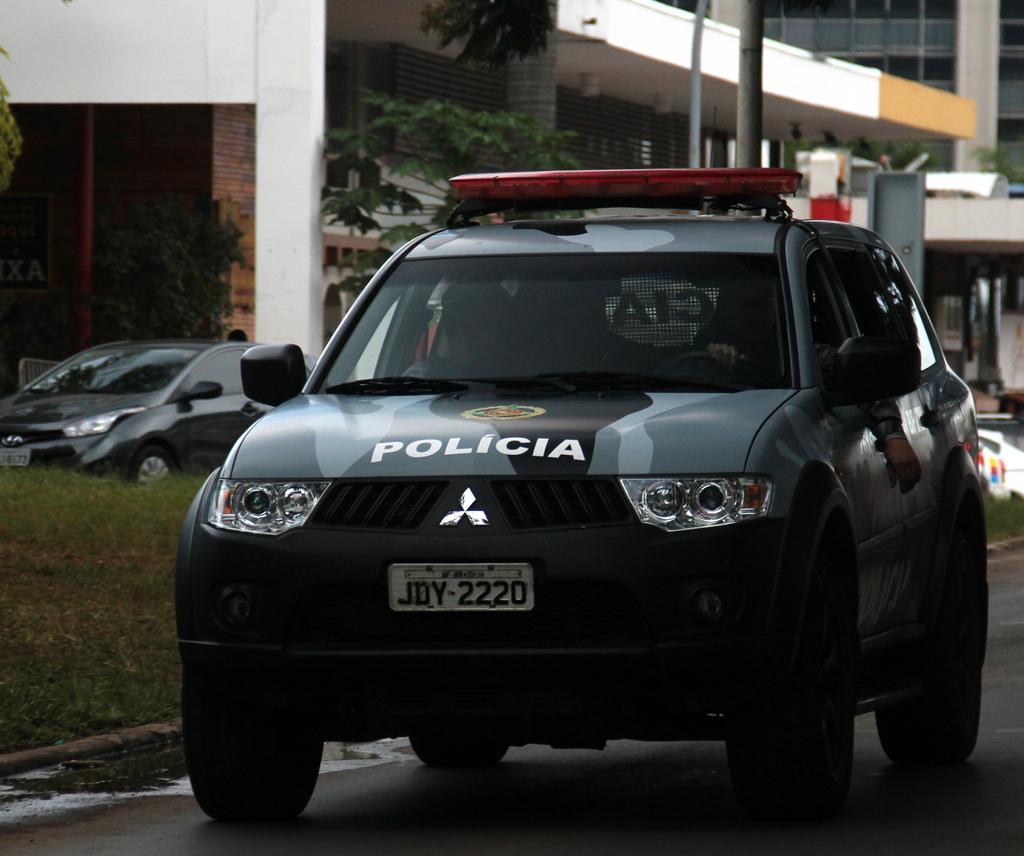How would you summarize this image in a sentence or two? In this image there are so many cars on the road behind them there are some buildings. 